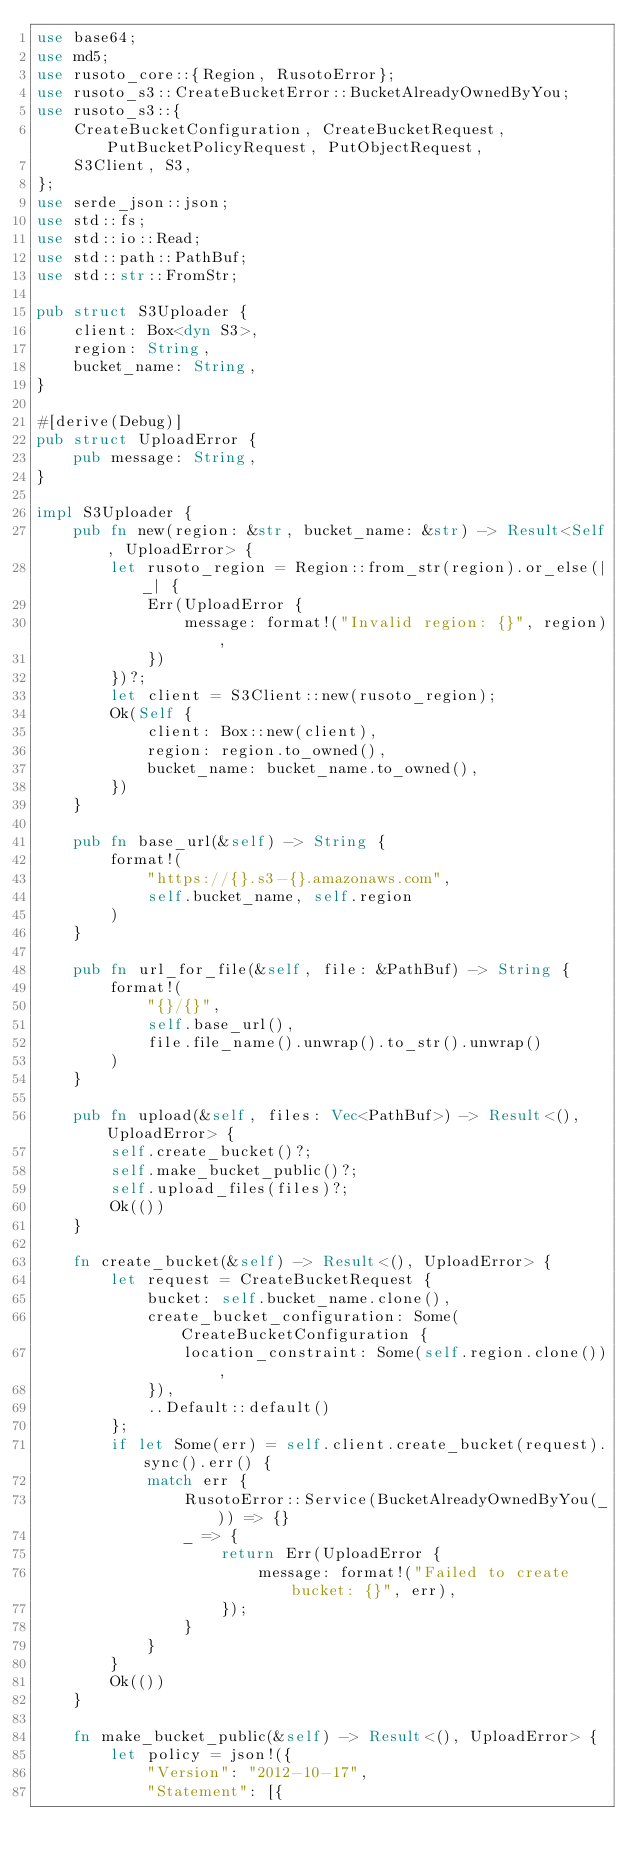Convert code to text. <code><loc_0><loc_0><loc_500><loc_500><_Rust_>use base64;
use md5;
use rusoto_core::{Region, RusotoError};
use rusoto_s3::CreateBucketError::BucketAlreadyOwnedByYou;
use rusoto_s3::{
    CreateBucketConfiguration, CreateBucketRequest, PutBucketPolicyRequest, PutObjectRequest,
    S3Client, S3,
};
use serde_json::json;
use std::fs;
use std::io::Read;
use std::path::PathBuf;
use std::str::FromStr;

pub struct S3Uploader {
    client: Box<dyn S3>,
    region: String,
    bucket_name: String,
}

#[derive(Debug)]
pub struct UploadError {
    pub message: String,
}

impl S3Uploader {
    pub fn new(region: &str, bucket_name: &str) -> Result<Self, UploadError> {
        let rusoto_region = Region::from_str(region).or_else(|_| {
            Err(UploadError {
                message: format!("Invalid region: {}", region),
            })
        })?;
        let client = S3Client::new(rusoto_region);
        Ok(Self {
            client: Box::new(client),
            region: region.to_owned(),
            bucket_name: bucket_name.to_owned(),
        })
    }

    pub fn base_url(&self) -> String {
        format!(
            "https://{}.s3-{}.amazonaws.com",
            self.bucket_name, self.region
        )
    }

    pub fn url_for_file(&self, file: &PathBuf) -> String {
        format!(
            "{}/{}",
            self.base_url(),
            file.file_name().unwrap().to_str().unwrap()
        )
    }

    pub fn upload(&self, files: Vec<PathBuf>) -> Result<(), UploadError> {
        self.create_bucket()?;
        self.make_bucket_public()?;
        self.upload_files(files)?;
        Ok(())
    }

    fn create_bucket(&self) -> Result<(), UploadError> {
        let request = CreateBucketRequest {
            bucket: self.bucket_name.clone(),
            create_bucket_configuration: Some(CreateBucketConfiguration {
                location_constraint: Some(self.region.clone()),
            }),
            ..Default::default()
        };
        if let Some(err) = self.client.create_bucket(request).sync().err() {
            match err {
                RusotoError::Service(BucketAlreadyOwnedByYou(_)) => {}
                _ => {
                    return Err(UploadError {
                        message: format!("Failed to create bucket: {}", err),
                    });
                }
            }
        }
        Ok(())
    }

    fn make_bucket_public(&self) -> Result<(), UploadError> {
        let policy = json!({
            "Version": "2012-10-17",
            "Statement": [{</code> 